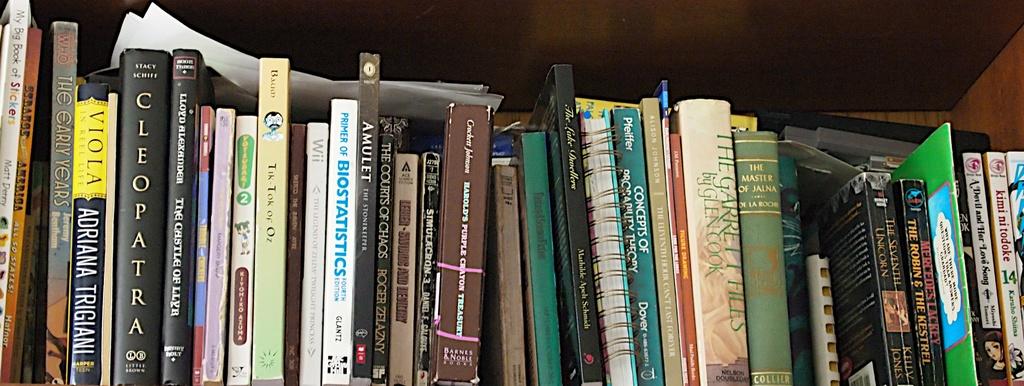Who is the author of the book cleopatra?
Your answer should be very brief. Stacy schiff. Who is the author of the garrett files?
Make the answer very short. Glen cook. 